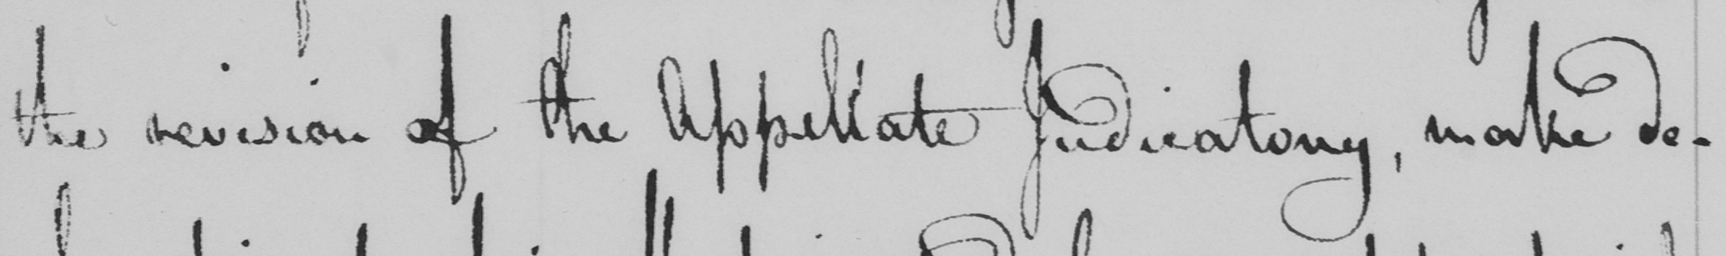What does this handwritten line say? the revision of the Appellate Judicatory , make de- 